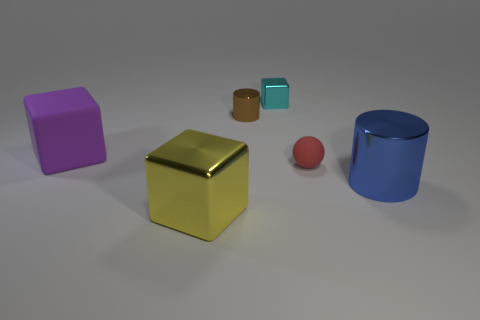Subtract all brown cylinders. How many cylinders are left? 1 Subtract all metallic cubes. How many cubes are left? 1 Subtract all cylinders. How many objects are left? 4 Subtract 1 cylinders. How many cylinders are left? 1 Subtract all purple cylinders. Subtract all red spheres. How many cylinders are left? 2 Subtract all brown spheres. How many cyan cubes are left? 1 Subtract all tiny red rubber balls. Subtract all blue metal things. How many objects are left? 4 Add 4 cyan metal blocks. How many cyan metal blocks are left? 5 Add 1 tiny brown metal cylinders. How many tiny brown metal cylinders exist? 2 Add 3 brown metallic cylinders. How many objects exist? 9 